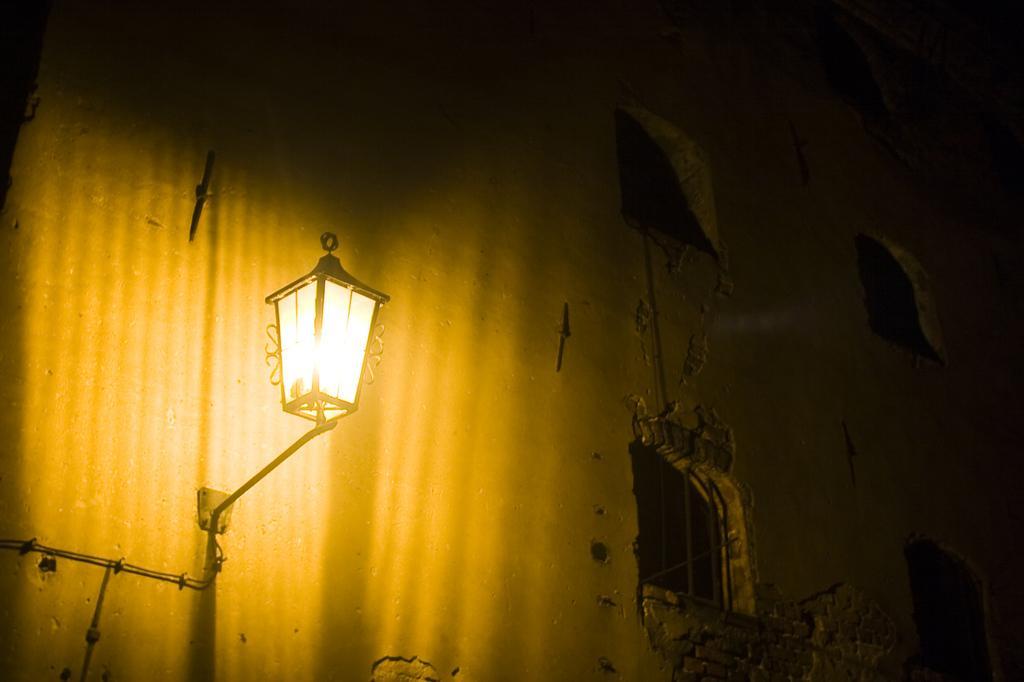Describe this image in one or two sentences. In this picture there is a building. On the building there are windows. Here there is a light. 